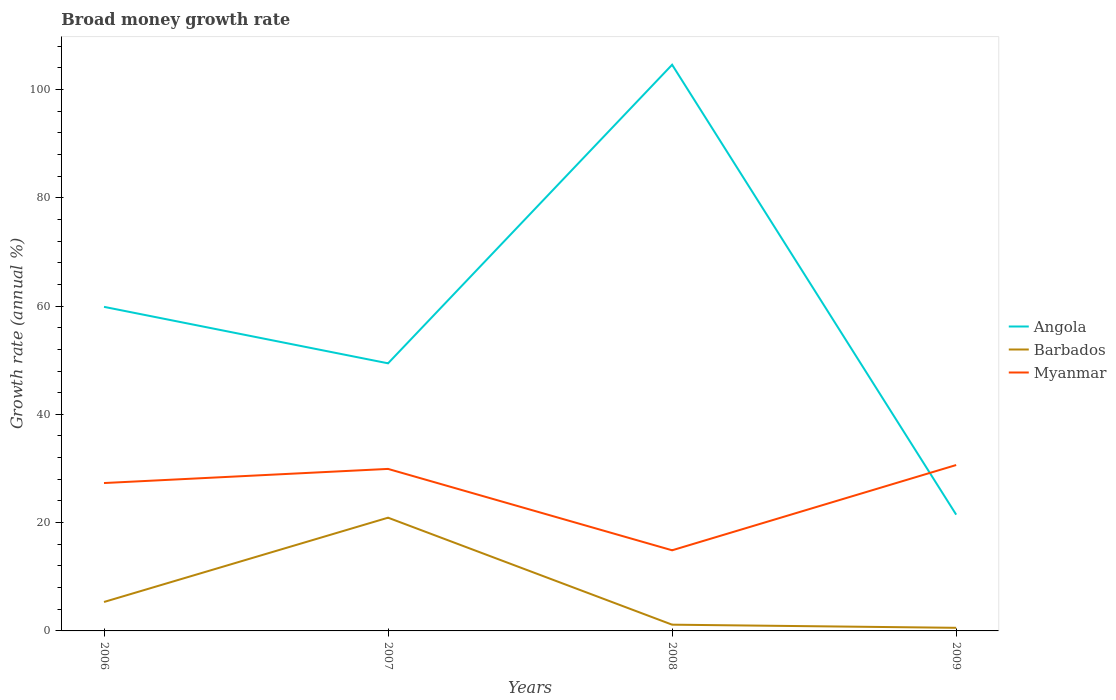Does the line corresponding to Myanmar intersect with the line corresponding to Angola?
Give a very brief answer. Yes. Is the number of lines equal to the number of legend labels?
Give a very brief answer. Yes. Across all years, what is the maximum growth rate in Myanmar?
Provide a succinct answer. 14.89. What is the total growth rate in Myanmar in the graph?
Your answer should be compact. 12.42. What is the difference between the highest and the second highest growth rate in Angola?
Your answer should be compact. 83.09. Is the growth rate in Barbados strictly greater than the growth rate in Angola over the years?
Make the answer very short. Yes. How many lines are there?
Your answer should be very brief. 3. How many years are there in the graph?
Your answer should be compact. 4. Does the graph contain any zero values?
Your answer should be compact. No. Does the graph contain grids?
Provide a short and direct response. No. How many legend labels are there?
Keep it short and to the point. 3. How are the legend labels stacked?
Your response must be concise. Vertical. What is the title of the graph?
Provide a succinct answer. Broad money growth rate. Does "Middle East & North Africa (developing only)" appear as one of the legend labels in the graph?
Ensure brevity in your answer.  No. What is the label or title of the X-axis?
Provide a succinct answer. Years. What is the label or title of the Y-axis?
Give a very brief answer. Growth rate (annual %). What is the Growth rate (annual %) of Angola in 2006?
Ensure brevity in your answer.  59.85. What is the Growth rate (annual %) in Barbados in 2006?
Make the answer very short. 5.35. What is the Growth rate (annual %) of Myanmar in 2006?
Offer a terse response. 27.31. What is the Growth rate (annual %) in Angola in 2007?
Provide a succinct answer. 49.42. What is the Growth rate (annual %) of Barbados in 2007?
Offer a terse response. 20.91. What is the Growth rate (annual %) in Myanmar in 2007?
Give a very brief answer. 29.92. What is the Growth rate (annual %) in Angola in 2008?
Make the answer very short. 104.57. What is the Growth rate (annual %) of Barbados in 2008?
Your answer should be compact. 1.15. What is the Growth rate (annual %) of Myanmar in 2008?
Provide a succinct answer. 14.89. What is the Growth rate (annual %) in Angola in 2009?
Your response must be concise. 21.48. What is the Growth rate (annual %) in Barbados in 2009?
Your answer should be compact. 0.57. What is the Growth rate (annual %) in Myanmar in 2009?
Ensure brevity in your answer.  30.64. Across all years, what is the maximum Growth rate (annual %) in Angola?
Keep it short and to the point. 104.57. Across all years, what is the maximum Growth rate (annual %) of Barbados?
Keep it short and to the point. 20.91. Across all years, what is the maximum Growth rate (annual %) in Myanmar?
Your answer should be very brief. 30.64. Across all years, what is the minimum Growth rate (annual %) of Angola?
Keep it short and to the point. 21.48. Across all years, what is the minimum Growth rate (annual %) of Barbados?
Offer a terse response. 0.57. Across all years, what is the minimum Growth rate (annual %) in Myanmar?
Provide a succinct answer. 14.89. What is the total Growth rate (annual %) of Angola in the graph?
Provide a short and direct response. 235.31. What is the total Growth rate (annual %) of Barbados in the graph?
Your answer should be compact. 27.98. What is the total Growth rate (annual %) in Myanmar in the graph?
Provide a short and direct response. 102.76. What is the difference between the Growth rate (annual %) in Angola in 2006 and that in 2007?
Keep it short and to the point. 10.43. What is the difference between the Growth rate (annual %) of Barbados in 2006 and that in 2007?
Make the answer very short. -15.57. What is the difference between the Growth rate (annual %) of Myanmar in 2006 and that in 2007?
Ensure brevity in your answer.  -2.61. What is the difference between the Growth rate (annual %) of Angola in 2006 and that in 2008?
Offer a very short reply. -44.72. What is the difference between the Growth rate (annual %) of Barbados in 2006 and that in 2008?
Ensure brevity in your answer.  4.19. What is the difference between the Growth rate (annual %) of Myanmar in 2006 and that in 2008?
Offer a terse response. 12.42. What is the difference between the Growth rate (annual %) in Angola in 2006 and that in 2009?
Your answer should be compact. 38.38. What is the difference between the Growth rate (annual %) of Barbados in 2006 and that in 2009?
Provide a succinct answer. 4.77. What is the difference between the Growth rate (annual %) in Myanmar in 2006 and that in 2009?
Your answer should be compact. -3.33. What is the difference between the Growth rate (annual %) in Angola in 2007 and that in 2008?
Make the answer very short. -55.14. What is the difference between the Growth rate (annual %) of Barbados in 2007 and that in 2008?
Make the answer very short. 19.76. What is the difference between the Growth rate (annual %) of Myanmar in 2007 and that in 2008?
Keep it short and to the point. 15.03. What is the difference between the Growth rate (annual %) of Angola in 2007 and that in 2009?
Your response must be concise. 27.95. What is the difference between the Growth rate (annual %) of Barbados in 2007 and that in 2009?
Provide a short and direct response. 20.34. What is the difference between the Growth rate (annual %) of Myanmar in 2007 and that in 2009?
Your answer should be very brief. -0.72. What is the difference between the Growth rate (annual %) in Angola in 2008 and that in 2009?
Offer a terse response. 83.09. What is the difference between the Growth rate (annual %) of Barbados in 2008 and that in 2009?
Provide a succinct answer. 0.58. What is the difference between the Growth rate (annual %) in Myanmar in 2008 and that in 2009?
Provide a short and direct response. -15.75. What is the difference between the Growth rate (annual %) in Angola in 2006 and the Growth rate (annual %) in Barbados in 2007?
Ensure brevity in your answer.  38.94. What is the difference between the Growth rate (annual %) in Angola in 2006 and the Growth rate (annual %) in Myanmar in 2007?
Your response must be concise. 29.93. What is the difference between the Growth rate (annual %) of Barbados in 2006 and the Growth rate (annual %) of Myanmar in 2007?
Provide a short and direct response. -24.58. What is the difference between the Growth rate (annual %) in Angola in 2006 and the Growth rate (annual %) in Barbados in 2008?
Your response must be concise. 58.7. What is the difference between the Growth rate (annual %) in Angola in 2006 and the Growth rate (annual %) in Myanmar in 2008?
Offer a terse response. 44.96. What is the difference between the Growth rate (annual %) in Barbados in 2006 and the Growth rate (annual %) in Myanmar in 2008?
Your response must be concise. -9.55. What is the difference between the Growth rate (annual %) in Angola in 2006 and the Growth rate (annual %) in Barbados in 2009?
Provide a short and direct response. 59.28. What is the difference between the Growth rate (annual %) of Angola in 2006 and the Growth rate (annual %) of Myanmar in 2009?
Your answer should be very brief. 29.21. What is the difference between the Growth rate (annual %) in Barbados in 2006 and the Growth rate (annual %) in Myanmar in 2009?
Keep it short and to the point. -25.29. What is the difference between the Growth rate (annual %) of Angola in 2007 and the Growth rate (annual %) of Barbados in 2008?
Give a very brief answer. 48.27. What is the difference between the Growth rate (annual %) in Angola in 2007 and the Growth rate (annual %) in Myanmar in 2008?
Make the answer very short. 34.53. What is the difference between the Growth rate (annual %) in Barbados in 2007 and the Growth rate (annual %) in Myanmar in 2008?
Your answer should be compact. 6.02. What is the difference between the Growth rate (annual %) of Angola in 2007 and the Growth rate (annual %) of Barbados in 2009?
Provide a short and direct response. 48.85. What is the difference between the Growth rate (annual %) in Angola in 2007 and the Growth rate (annual %) in Myanmar in 2009?
Provide a succinct answer. 18.78. What is the difference between the Growth rate (annual %) of Barbados in 2007 and the Growth rate (annual %) of Myanmar in 2009?
Give a very brief answer. -9.73. What is the difference between the Growth rate (annual %) in Angola in 2008 and the Growth rate (annual %) in Barbados in 2009?
Keep it short and to the point. 103.99. What is the difference between the Growth rate (annual %) in Angola in 2008 and the Growth rate (annual %) in Myanmar in 2009?
Offer a very short reply. 73.93. What is the difference between the Growth rate (annual %) in Barbados in 2008 and the Growth rate (annual %) in Myanmar in 2009?
Your answer should be compact. -29.48. What is the average Growth rate (annual %) of Angola per year?
Keep it short and to the point. 58.83. What is the average Growth rate (annual %) of Barbados per year?
Offer a very short reply. 7. What is the average Growth rate (annual %) in Myanmar per year?
Ensure brevity in your answer.  25.69. In the year 2006, what is the difference between the Growth rate (annual %) of Angola and Growth rate (annual %) of Barbados?
Make the answer very short. 54.51. In the year 2006, what is the difference between the Growth rate (annual %) of Angola and Growth rate (annual %) of Myanmar?
Give a very brief answer. 32.54. In the year 2006, what is the difference between the Growth rate (annual %) in Barbados and Growth rate (annual %) in Myanmar?
Provide a short and direct response. -21.97. In the year 2007, what is the difference between the Growth rate (annual %) of Angola and Growth rate (annual %) of Barbados?
Provide a short and direct response. 28.51. In the year 2007, what is the difference between the Growth rate (annual %) in Angola and Growth rate (annual %) in Myanmar?
Make the answer very short. 19.5. In the year 2007, what is the difference between the Growth rate (annual %) of Barbados and Growth rate (annual %) of Myanmar?
Keep it short and to the point. -9.01. In the year 2008, what is the difference between the Growth rate (annual %) in Angola and Growth rate (annual %) in Barbados?
Give a very brief answer. 103.41. In the year 2008, what is the difference between the Growth rate (annual %) of Angola and Growth rate (annual %) of Myanmar?
Your answer should be compact. 89.67. In the year 2008, what is the difference between the Growth rate (annual %) of Barbados and Growth rate (annual %) of Myanmar?
Give a very brief answer. -13.74. In the year 2009, what is the difference between the Growth rate (annual %) of Angola and Growth rate (annual %) of Barbados?
Offer a very short reply. 20.9. In the year 2009, what is the difference between the Growth rate (annual %) of Angola and Growth rate (annual %) of Myanmar?
Keep it short and to the point. -9.16. In the year 2009, what is the difference between the Growth rate (annual %) in Barbados and Growth rate (annual %) in Myanmar?
Your answer should be compact. -30.06. What is the ratio of the Growth rate (annual %) of Angola in 2006 to that in 2007?
Ensure brevity in your answer.  1.21. What is the ratio of the Growth rate (annual %) of Barbados in 2006 to that in 2007?
Your answer should be compact. 0.26. What is the ratio of the Growth rate (annual %) of Myanmar in 2006 to that in 2007?
Provide a short and direct response. 0.91. What is the ratio of the Growth rate (annual %) of Angola in 2006 to that in 2008?
Your answer should be compact. 0.57. What is the ratio of the Growth rate (annual %) in Barbados in 2006 to that in 2008?
Provide a short and direct response. 4.63. What is the ratio of the Growth rate (annual %) in Myanmar in 2006 to that in 2008?
Provide a succinct answer. 1.83. What is the ratio of the Growth rate (annual %) of Angola in 2006 to that in 2009?
Provide a short and direct response. 2.79. What is the ratio of the Growth rate (annual %) of Barbados in 2006 to that in 2009?
Offer a very short reply. 9.33. What is the ratio of the Growth rate (annual %) of Myanmar in 2006 to that in 2009?
Offer a very short reply. 0.89. What is the ratio of the Growth rate (annual %) of Angola in 2007 to that in 2008?
Offer a very short reply. 0.47. What is the ratio of the Growth rate (annual %) of Barbados in 2007 to that in 2008?
Make the answer very short. 18.12. What is the ratio of the Growth rate (annual %) in Myanmar in 2007 to that in 2008?
Give a very brief answer. 2.01. What is the ratio of the Growth rate (annual %) of Angola in 2007 to that in 2009?
Ensure brevity in your answer.  2.3. What is the ratio of the Growth rate (annual %) of Barbados in 2007 to that in 2009?
Your response must be concise. 36.49. What is the ratio of the Growth rate (annual %) in Myanmar in 2007 to that in 2009?
Provide a succinct answer. 0.98. What is the ratio of the Growth rate (annual %) of Angola in 2008 to that in 2009?
Your answer should be compact. 4.87. What is the ratio of the Growth rate (annual %) of Barbados in 2008 to that in 2009?
Your answer should be very brief. 2.01. What is the ratio of the Growth rate (annual %) of Myanmar in 2008 to that in 2009?
Your answer should be very brief. 0.49. What is the difference between the highest and the second highest Growth rate (annual %) of Angola?
Ensure brevity in your answer.  44.72. What is the difference between the highest and the second highest Growth rate (annual %) of Barbados?
Give a very brief answer. 15.57. What is the difference between the highest and the second highest Growth rate (annual %) in Myanmar?
Your response must be concise. 0.72. What is the difference between the highest and the lowest Growth rate (annual %) of Angola?
Your answer should be compact. 83.09. What is the difference between the highest and the lowest Growth rate (annual %) of Barbados?
Offer a very short reply. 20.34. What is the difference between the highest and the lowest Growth rate (annual %) in Myanmar?
Offer a very short reply. 15.75. 